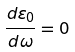Convert formula to latex. <formula><loc_0><loc_0><loc_500><loc_500>\frac { d \varepsilon _ { 0 } } { d \omega } = 0</formula> 